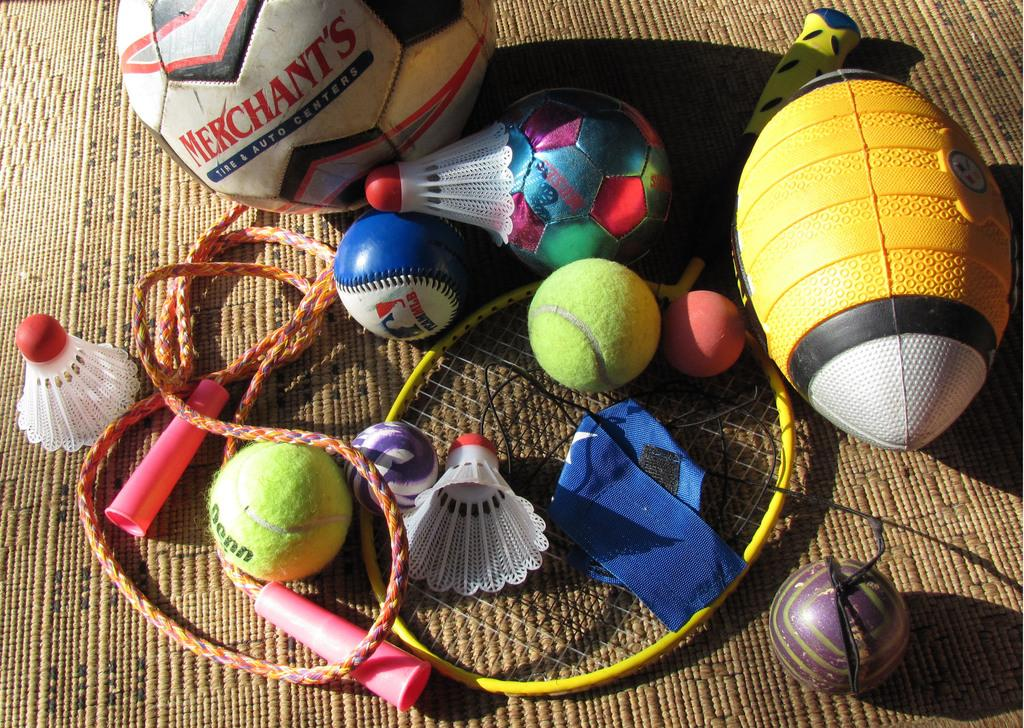What type of objects can be seen in the image? There are corks, a skipping rope, balls, and a shuttle bat in the image. What might these objects be used for? The corks, balls, and shuttle bat are commonly used in sports or games, while the skipping rope is used for exercise. Where are these objects located? The objects are on a mat in the image. What type of rhythm can be heard coming from the objects in the image? There is no sound or rhythm present in the image, as it only shows objects and does not depict any audible elements. 